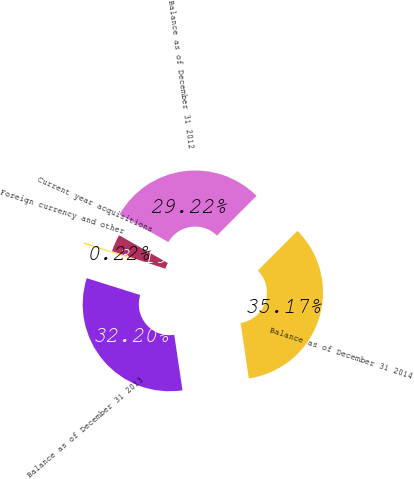<chart> <loc_0><loc_0><loc_500><loc_500><pie_chart><fcel>Balance as of December 31 2012<fcel>Current year acquisitions<fcel>Foreign currency and other<fcel>Balance as of December 31 2013<fcel>Balance as of December 31 2014<nl><fcel>29.22%<fcel>3.19%<fcel>0.22%<fcel>32.2%<fcel>35.17%<nl></chart> 